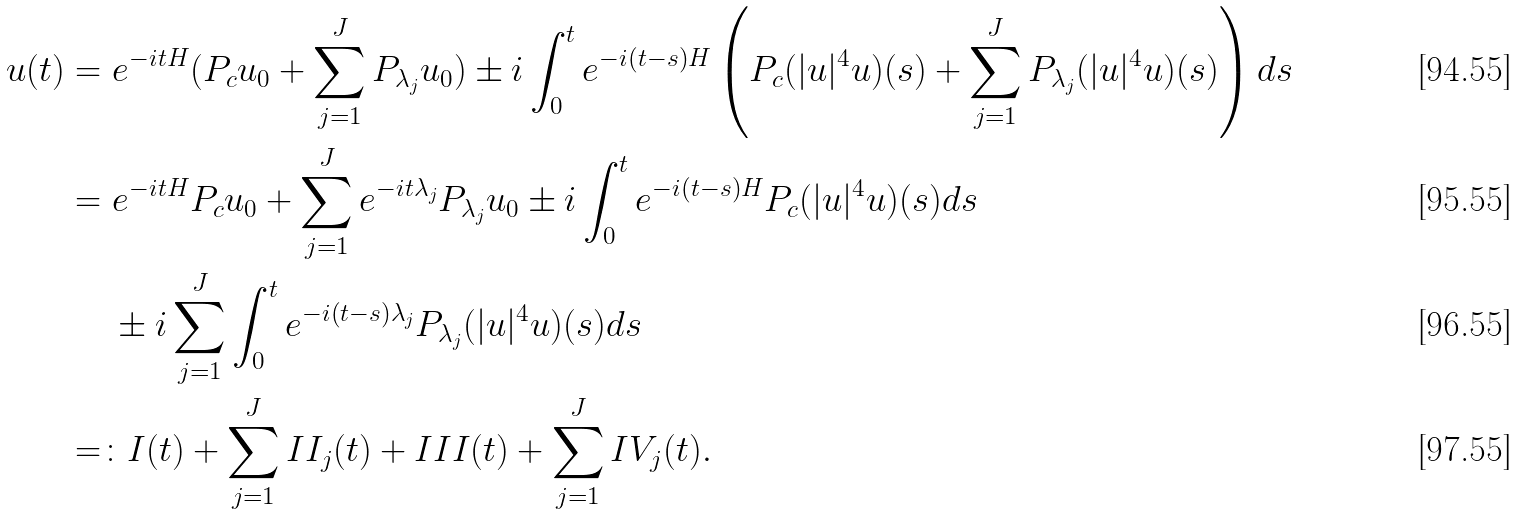Convert formula to latex. <formula><loc_0><loc_0><loc_500><loc_500>u ( t ) & = e ^ { - i t H } ( P _ { c } u _ { 0 } + \sum _ { j = 1 } ^ { J } P _ { \lambda _ { j } } u _ { 0 } ) \pm i \int _ { 0 } ^ { t } e ^ { - i ( t - s ) H } \left ( P _ { c } ( | u | ^ { 4 } u ) ( s ) + \sum _ { j = 1 } ^ { J } P _ { \lambda _ { j } } ( | u | ^ { 4 } u ) ( s ) \right ) d s \\ & = e ^ { - i t H } P _ { c } u _ { 0 } + \sum _ { j = 1 } ^ { J } e ^ { - i t \lambda _ { j } } P _ { \lambda _ { j } } u _ { 0 } \pm i \int _ { 0 } ^ { t } e ^ { - i ( t - s ) H } P _ { c } ( | u | ^ { 4 } u ) ( s ) d s \\ & \quad \ \pm i \sum _ { j = 1 } ^ { J } \int _ { 0 } ^ { t } e ^ { - i ( t - s ) \lambda _ { j } } P _ { \lambda _ { j } } ( | u | ^ { 4 } u ) ( s ) d s \\ & = \colon I ( t ) + \sum _ { j = 1 } ^ { J } I I _ { j } ( t ) + I I I ( t ) + \sum _ { j = 1 } ^ { J } I V _ { j } ( t ) .</formula> 